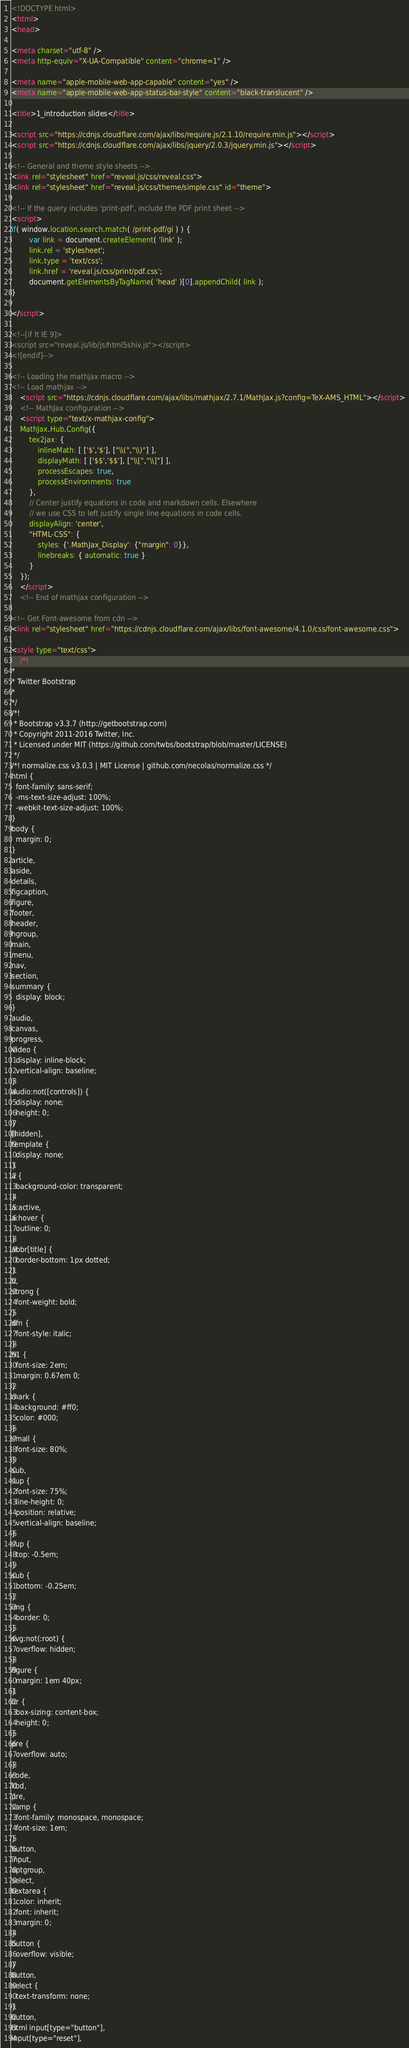Convert code to text. <code><loc_0><loc_0><loc_500><loc_500><_HTML_>
<!DOCTYPE html>
<html>
<head>

<meta charset="utf-8" />
<meta http-equiv="X-UA-Compatible" content="chrome=1" />

<meta name="apple-mobile-web-app-capable" content="yes" />
<meta name="apple-mobile-web-app-status-bar-style" content="black-translucent" />

<title>1_introduction slides</title>

<script src="https://cdnjs.cloudflare.com/ajax/libs/require.js/2.1.10/require.min.js"></script>
<script src="https://cdnjs.cloudflare.com/ajax/libs/jquery/2.0.3/jquery.min.js"></script>

<!-- General and theme style sheets -->
<link rel="stylesheet" href="reveal.js/css/reveal.css">
<link rel="stylesheet" href="reveal.js/css/theme/simple.css" id="theme">

<!-- If the query includes 'print-pdf', include the PDF print sheet -->
<script>
if( window.location.search.match( /print-pdf/gi ) ) {
        var link = document.createElement( 'link' );
        link.rel = 'stylesheet';
        link.type = 'text/css';
        link.href = 'reveal.js/css/print/pdf.css';
        document.getElementsByTagName( 'head' )[0].appendChild( link );
}

</script>

<!--[if lt IE 9]>
<script src="reveal.js/lib/js/html5shiv.js"></script>
<![endif]-->

<!-- Loading the mathjax macro -->
<!-- Load mathjax -->
    <script src="https://cdnjs.cloudflare.com/ajax/libs/mathjax/2.7.1/MathJax.js?config=TeX-AMS_HTML"></script>
    <!-- MathJax configuration -->
    <script type="text/x-mathjax-config">
    MathJax.Hub.Config({
        tex2jax: {
            inlineMath: [ ['$','$'], ["\\(","\\)"] ],
            displayMath: [ ['$$','$$'], ["\\[","\\]"] ],
            processEscapes: true,
            processEnvironments: true
        },
        // Center justify equations in code and markdown cells. Elsewhere
        // we use CSS to left justify single line equations in code cells.
        displayAlign: 'center',
        "HTML-CSS": {
            styles: {'.MathJax_Display': {"margin": 0}},
            linebreaks: { automatic: true }
        }
    });
    </script>
    <!-- End of mathjax configuration -->

<!-- Get Font-awesome from cdn -->
<link rel="stylesheet" href="https://cdnjs.cloudflare.com/ajax/libs/font-awesome/4.1.0/css/font-awesome.css">

<style type="text/css">
    /*!
*
* Twitter Bootstrap
*
*/
/*!
 * Bootstrap v3.3.7 (http://getbootstrap.com)
 * Copyright 2011-2016 Twitter, Inc.
 * Licensed under MIT (https://github.com/twbs/bootstrap/blob/master/LICENSE)
 */
/*! normalize.css v3.0.3 | MIT License | github.com/necolas/normalize.css */
html {
  font-family: sans-serif;
  -ms-text-size-adjust: 100%;
  -webkit-text-size-adjust: 100%;
}
body {
  margin: 0;
}
article,
aside,
details,
figcaption,
figure,
footer,
header,
hgroup,
main,
menu,
nav,
section,
summary {
  display: block;
}
audio,
canvas,
progress,
video {
  display: inline-block;
  vertical-align: baseline;
}
audio:not([controls]) {
  display: none;
  height: 0;
}
[hidden],
template {
  display: none;
}
a {
  background-color: transparent;
}
a:active,
a:hover {
  outline: 0;
}
abbr[title] {
  border-bottom: 1px dotted;
}
b,
strong {
  font-weight: bold;
}
dfn {
  font-style: italic;
}
h1 {
  font-size: 2em;
  margin: 0.67em 0;
}
mark {
  background: #ff0;
  color: #000;
}
small {
  font-size: 80%;
}
sub,
sup {
  font-size: 75%;
  line-height: 0;
  position: relative;
  vertical-align: baseline;
}
sup {
  top: -0.5em;
}
sub {
  bottom: -0.25em;
}
img {
  border: 0;
}
svg:not(:root) {
  overflow: hidden;
}
figure {
  margin: 1em 40px;
}
hr {
  box-sizing: content-box;
  height: 0;
}
pre {
  overflow: auto;
}
code,
kbd,
pre,
samp {
  font-family: monospace, monospace;
  font-size: 1em;
}
button,
input,
optgroup,
select,
textarea {
  color: inherit;
  font: inherit;
  margin: 0;
}
button {
  overflow: visible;
}
button,
select {
  text-transform: none;
}
button,
html input[type="button"],
input[type="reset"],</code> 